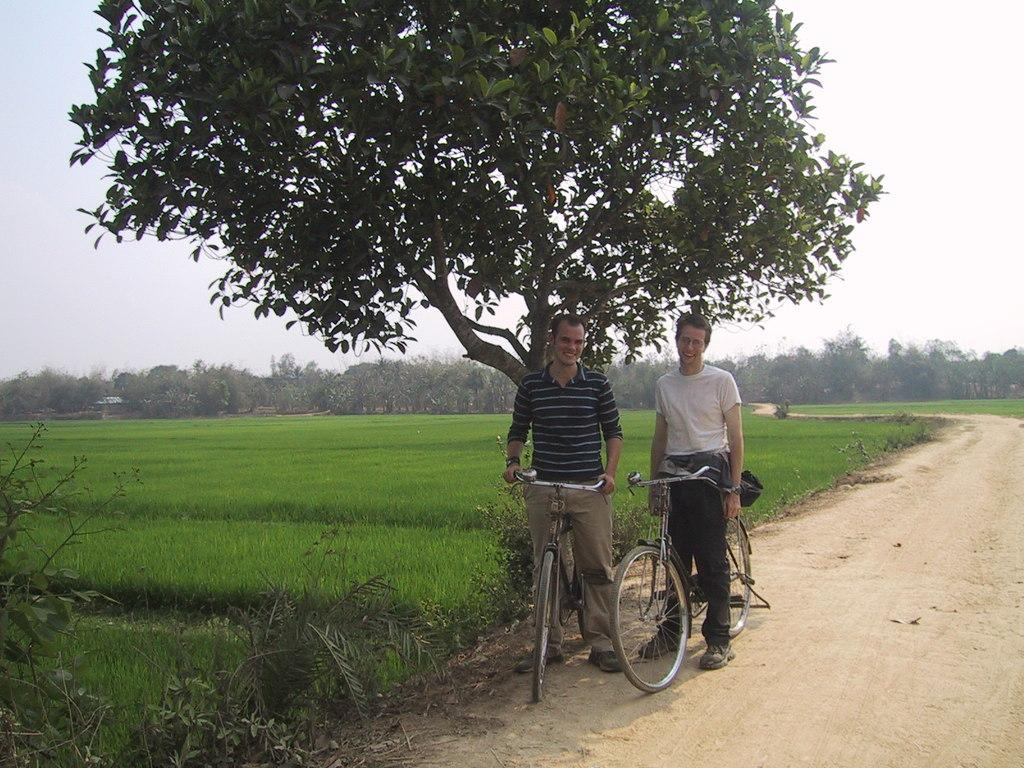How many men are in the image? There are two men in the image. What are the men doing in the image? The men are standing on a bicycle. What can be seen in the background of the image? There is a tree, a paddy field, a group of trees, and a road in the background. What is the condition of the sky in the image? The sky is visible and there are no clouds. How does the swim effect the cattle in the image? There is no swim or cattle present in the image. 